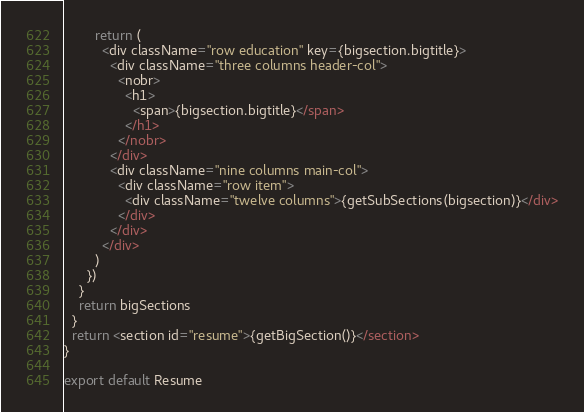Convert code to text. <code><loc_0><loc_0><loc_500><loc_500><_JavaScript_>        return (
          <div className="row education" key={bigsection.bigtitle}>
            <div className="three columns header-col">
              <nobr>
                <h1>
                  <span>{bigsection.bigtitle}</span>
                </h1>
              </nobr>
            </div>
            <div className="nine columns main-col">
              <div className="row item">
                <div className="twelve columns">{getSubSections(bigsection)}</div>
              </div>
            </div>
          </div>
        )
      })
    }
    return bigSections
  }
  return <section id="resume">{getBigSection()}</section>
}

export default Resume
</code> 